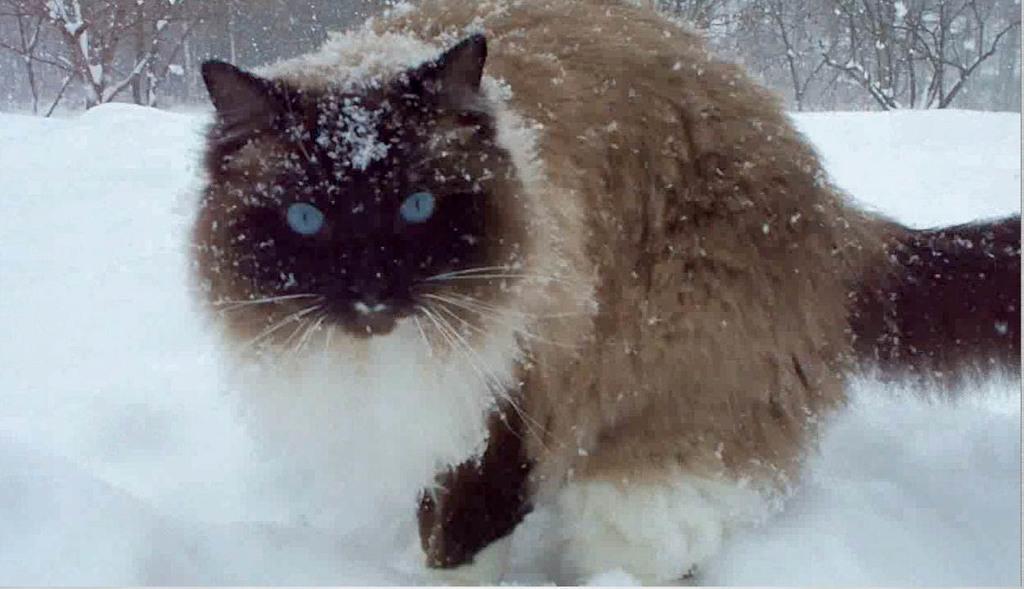In one or two sentences, can you explain what this image depicts? In the foreground of the picture there is a cat and there is snow. In the background there are trees. 